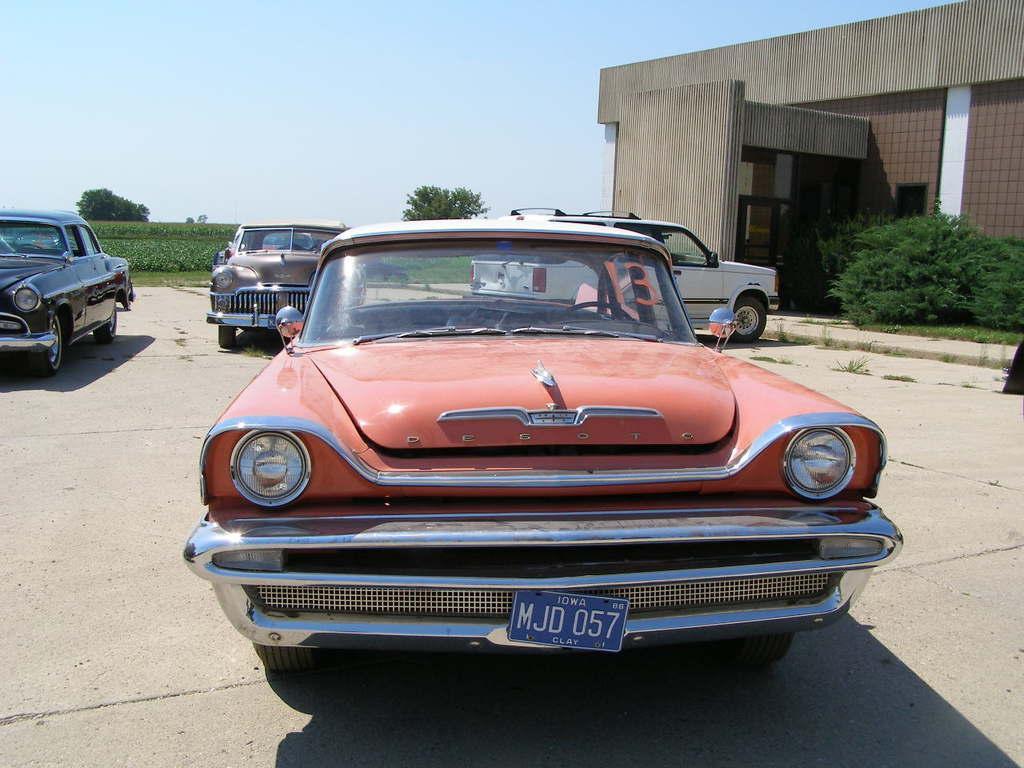Describe this image in one or two sentences. In this image we can see cars on the road. To the right side of the image there is a building. There are trees, plants. At the top of the image there is sky. 